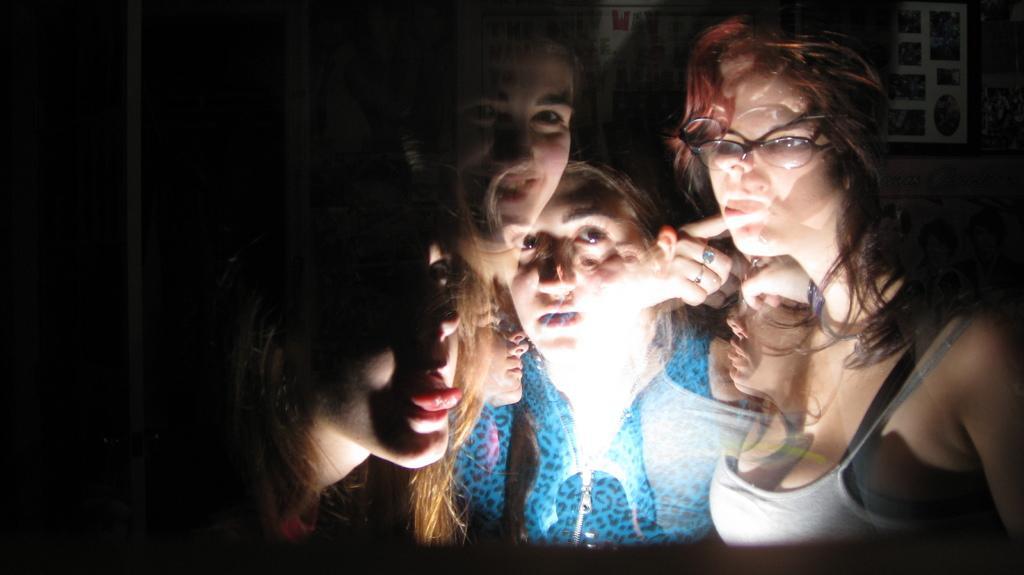Describe this image in one or two sentences. The image is clicked in the reflection of a mirror or a glass. In the image there are women and a light. On the left it is dark. 